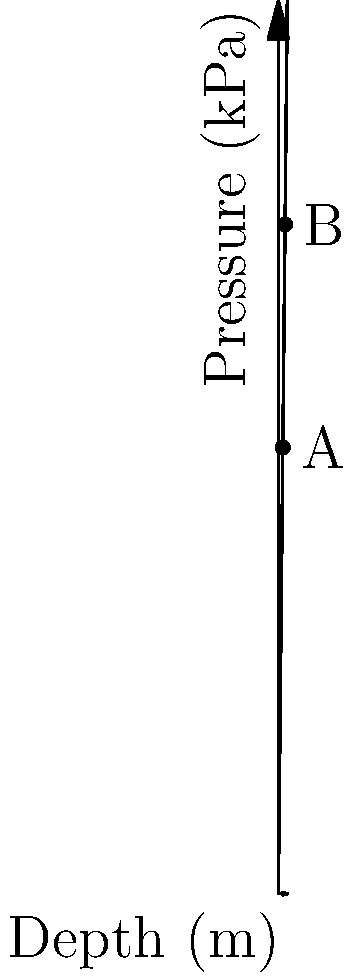The graph shows the relationship between ocean depth and pressure. Point A represents a depth of 50 meters. If a marine biologist wants to study deep-sea creatures at point B, how much deeper would they need to dive from point A, and what would be the increase in pressure? Let's approach this step-by-step:

1) First, we need to identify the coordinates of points A and B:
   Point A: (50 m, 5000 kPa)
   Point B: (75 m, 7500 kPa)

2) To find how much deeper point B is compared to point A:
   Depth difference = Depth at B - Depth at A
   $$ 75 \text{ m} - 50 \text{ m} = 25 \text{ m} $$

3) To calculate the increase in pressure:
   Pressure difference = Pressure at B - Pressure at A
   $$ 7500 \text{ kPa} - 5000 \text{ kPa} = 2500 \text{ kPa} $$

4) We can also verify this using the relationship shown in the graph:
   Pressure increases by 100 kPa for every 1 m increase in depth.
   For a 25 m increase: $25 \times 100 \text{ kPa} = 2500 \text{ kPa}$

Therefore, the marine biologist would need to dive 25 m deeper, and the pressure would increase by 2500 kPa.
Answer: 25 m deeper; 2500 kPa increase 